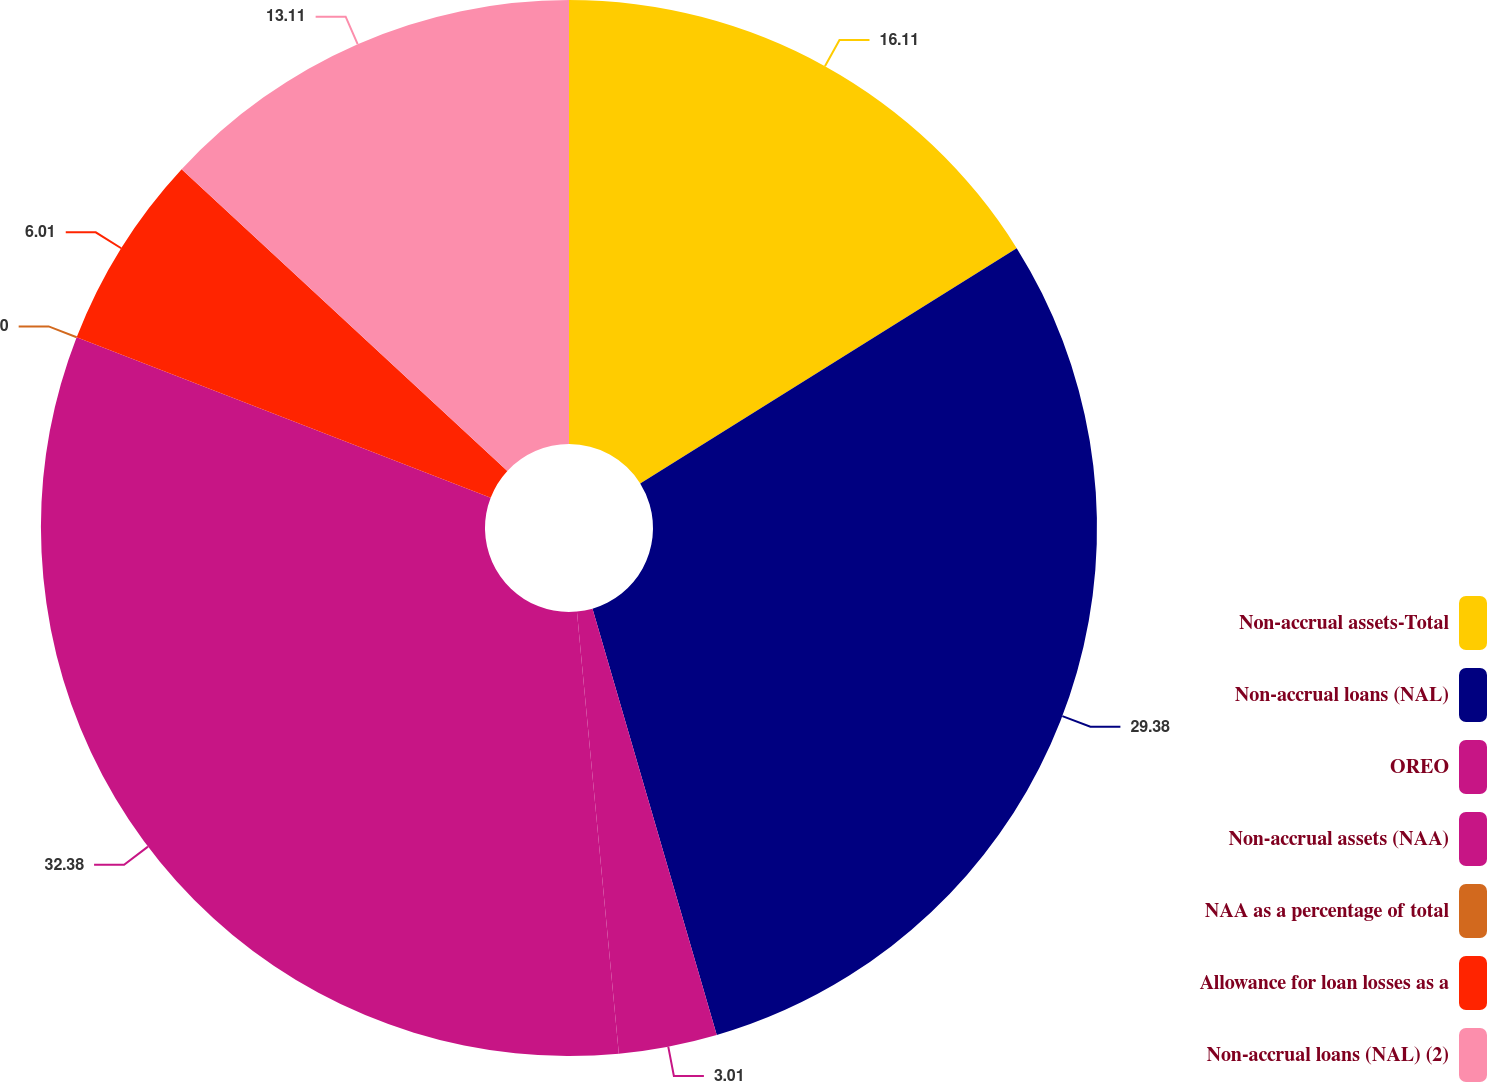Convert chart to OTSL. <chart><loc_0><loc_0><loc_500><loc_500><pie_chart><fcel>Non-accrual assets-Total<fcel>Non-accrual loans (NAL)<fcel>OREO<fcel>Non-accrual assets (NAA)<fcel>NAA as a percentage of total<fcel>Allowance for loan losses as a<fcel>Non-accrual loans (NAL) (2)<nl><fcel>16.11%<fcel>29.38%<fcel>3.01%<fcel>32.39%<fcel>0.0%<fcel>6.01%<fcel>13.11%<nl></chart> 